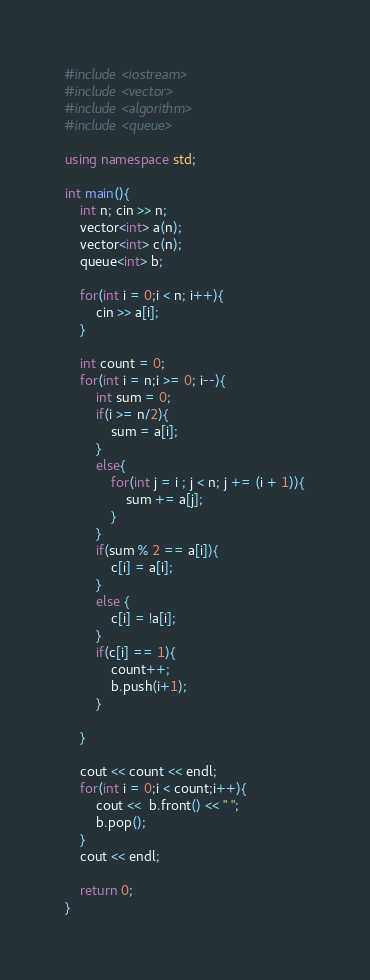Convert code to text. <code><loc_0><loc_0><loc_500><loc_500><_C++_>#include <iostream>
#include <vector>
#include <algorithm>
#include <queue>

using namespace std;

int main(){
    int n; cin >> n;
    vector<int> a(n);
    vector<int> c(n);
    queue<int> b;

    for(int i = 0;i < n; i++){
        cin >> a[i];
    }

    int count = 0;
    for(int i = n;i >= 0; i--){
        int sum = 0;
        if(i >= n/2){
            sum = a[i];
        }
        else{
            for(int j = i ; j < n; j += (i + 1)){
                sum += a[j];
            }
        }
        if(sum % 2 == a[i]){
            c[i] = a[i];
        }
        else {
            c[i] = !a[i];
        }
        if(c[i] == 1){
            count++;
            b.push(i+1);
        }
        
    }

    cout << count << endl;
    for(int i = 0;i < count;i++){
        cout <<  b.front() << " ";
        b.pop();
    }
    cout << endl;

    return 0;
}</code> 